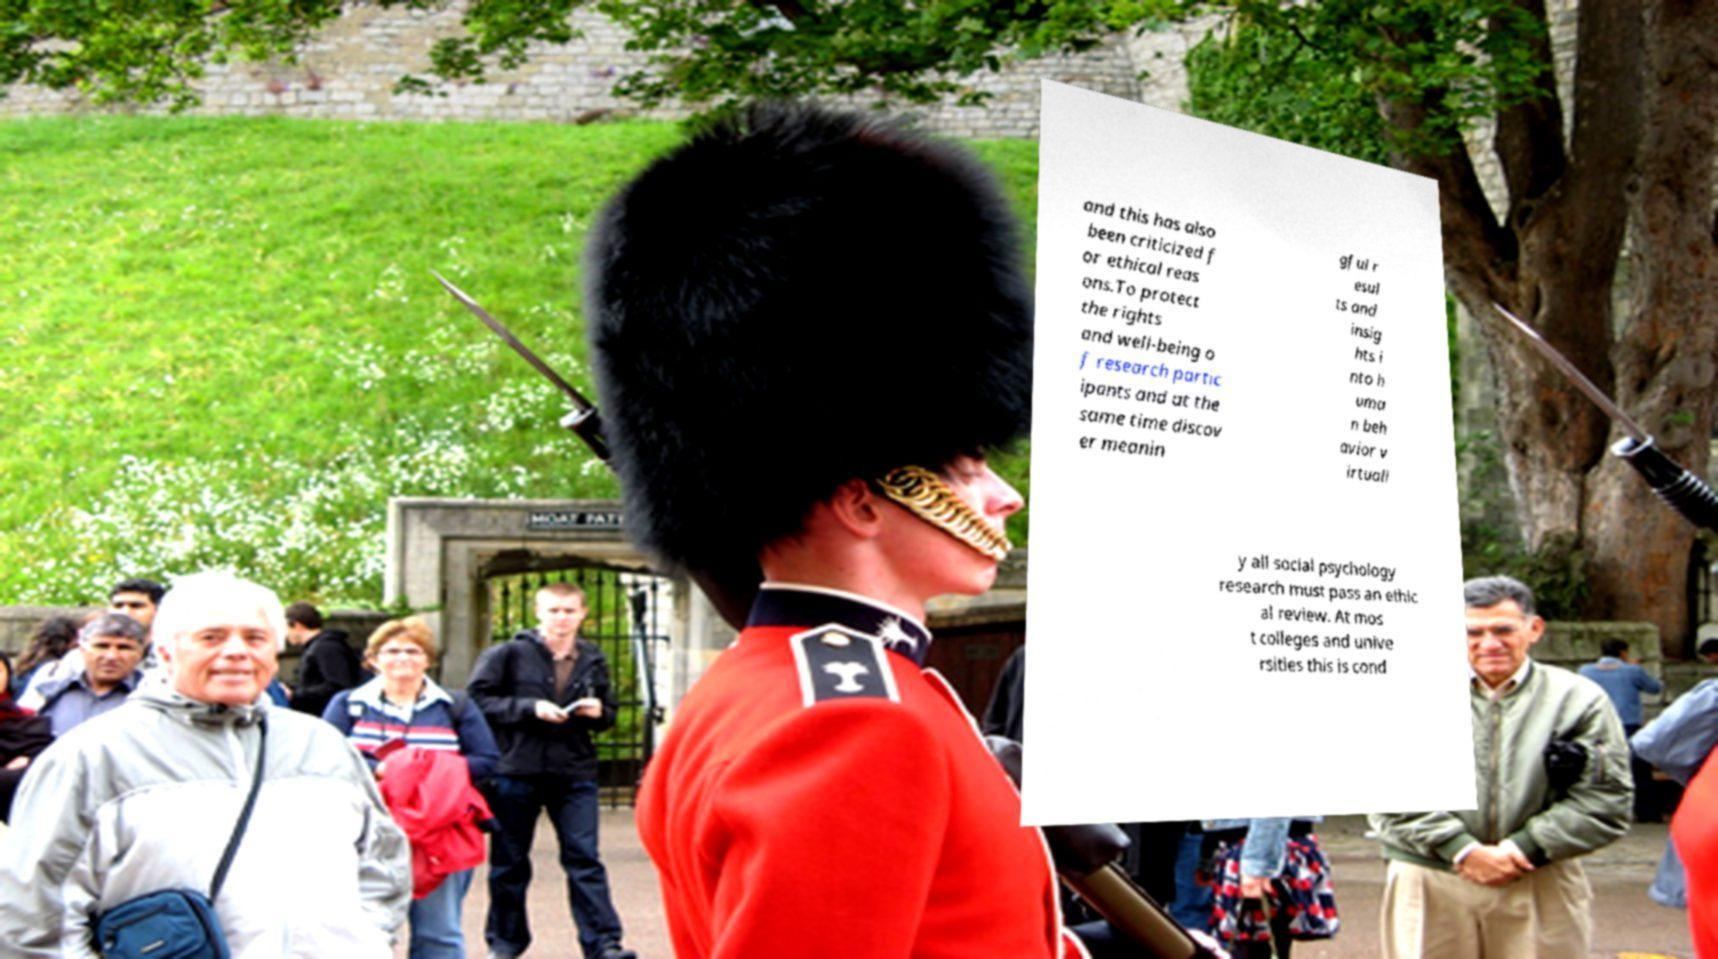I need the written content from this picture converted into text. Can you do that? and this has also been criticized f or ethical reas ons.To protect the rights and well-being o f research partic ipants and at the same time discov er meanin gful r esul ts and insig hts i nto h uma n beh avior v irtuall y all social psychology research must pass an ethic al review. At mos t colleges and unive rsities this is cond 